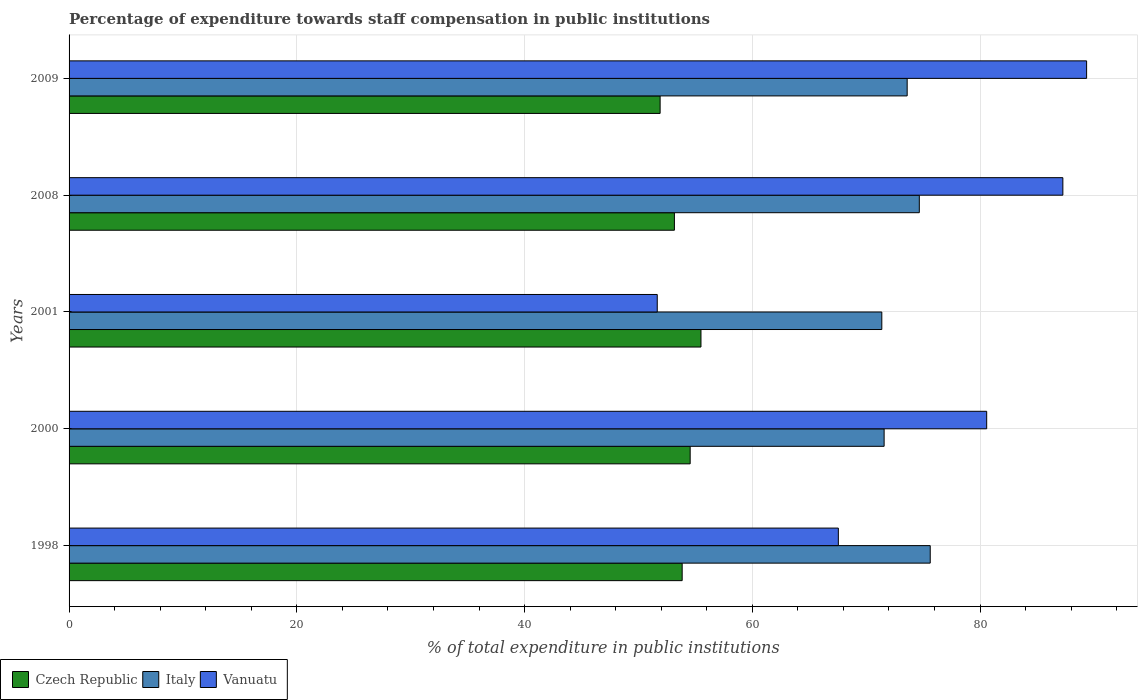How many groups of bars are there?
Your answer should be very brief. 5. Are the number of bars on each tick of the Y-axis equal?
Provide a succinct answer. Yes. What is the label of the 4th group of bars from the top?
Your answer should be compact. 2000. In how many cases, is the number of bars for a given year not equal to the number of legend labels?
Provide a short and direct response. 0. What is the percentage of expenditure towards staff compensation in Vanuatu in 2001?
Give a very brief answer. 51.65. Across all years, what is the maximum percentage of expenditure towards staff compensation in Vanuatu?
Ensure brevity in your answer.  89.36. Across all years, what is the minimum percentage of expenditure towards staff compensation in Italy?
Your response must be concise. 71.37. In which year was the percentage of expenditure towards staff compensation in Vanuatu maximum?
Offer a terse response. 2009. What is the total percentage of expenditure towards staff compensation in Czech Republic in the graph?
Your answer should be very brief. 268.95. What is the difference between the percentage of expenditure towards staff compensation in Italy in 2000 and that in 2009?
Your response must be concise. -2.02. What is the difference between the percentage of expenditure towards staff compensation in Vanuatu in 2009 and the percentage of expenditure towards staff compensation in Czech Republic in 2008?
Your answer should be compact. 36.2. What is the average percentage of expenditure towards staff compensation in Czech Republic per year?
Keep it short and to the point. 53.79. In the year 1998, what is the difference between the percentage of expenditure towards staff compensation in Czech Republic and percentage of expenditure towards staff compensation in Vanuatu?
Your answer should be compact. -13.71. What is the ratio of the percentage of expenditure towards staff compensation in Vanuatu in 2000 to that in 2008?
Your response must be concise. 0.92. Is the percentage of expenditure towards staff compensation in Italy in 2000 less than that in 2009?
Make the answer very short. Yes. Is the difference between the percentage of expenditure towards staff compensation in Czech Republic in 1998 and 2008 greater than the difference between the percentage of expenditure towards staff compensation in Vanuatu in 1998 and 2008?
Provide a short and direct response. Yes. What is the difference between the highest and the second highest percentage of expenditure towards staff compensation in Vanuatu?
Provide a short and direct response. 2.09. What is the difference between the highest and the lowest percentage of expenditure towards staff compensation in Vanuatu?
Your response must be concise. 37.71. What does the 2nd bar from the top in 2001 represents?
Provide a short and direct response. Italy. What does the 2nd bar from the bottom in 1998 represents?
Provide a succinct answer. Italy. How many bars are there?
Make the answer very short. 15. How many years are there in the graph?
Your answer should be very brief. 5. What is the difference between two consecutive major ticks on the X-axis?
Keep it short and to the point. 20. Are the values on the major ticks of X-axis written in scientific E-notation?
Your answer should be compact. No. Does the graph contain any zero values?
Ensure brevity in your answer.  No. Does the graph contain grids?
Your answer should be compact. Yes. How are the legend labels stacked?
Ensure brevity in your answer.  Horizontal. What is the title of the graph?
Ensure brevity in your answer.  Percentage of expenditure towards staff compensation in public institutions. What is the label or title of the X-axis?
Ensure brevity in your answer.  % of total expenditure in public institutions. What is the label or title of the Y-axis?
Your response must be concise. Years. What is the % of total expenditure in public institutions of Czech Republic in 1998?
Provide a succinct answer. 53.84. What is the % of total expenditure in public institutions in Italy in 1998?
Provide a short and direct response. 75.63. What is the % of total expenditure in public institutions of Vanuatu in 1998?
Ensure brevity in your answer.  67.56. What is the % of total expenditure in public institutions in Czech Republic in 2000?
Your answer should be compact. 54.54. What is the % of total expenditure in public institutions in Italy in 2000?
Ensure brevity in your answer.  71.58. What is the % of total expenditure in public institutions of Vanuatu in 2000?
Ensure brevity in your answer.  80.58. What is the % of total expenditure in public institutions in Czech Republic in 2001?
Offer a terse response. 55.49. What is the % of total expenditure in public institutions of Italy in 2001?
Ensure brevity in your answer.  71.37. What is the % of total expenditure in public institutions in Vanuatu in 2001?
Your answer should be compact. 51.65. What is the % of total expenditure in public institutions in Czech Republic in 2008?
Your answer should be compact. 53.16. What is the % of total expenditure in public institutions in Italy in 2008?
Ensure brevity in your answer.  74.67. What is the % of total expenditure in public institutions of Vanuatu in 2008?
Ensure brevity in your answer.  87.27. What is the % of total expenditure in public institutions of Czech Republic in 2009?
Keep it short and to the point. 51.91. What is the % of total expenditure in public institutions in Italy in 2009?
Ensure brevity in your answer.  73.6. What is the % of total expenditure in public institutions in Vanuatu in 2009?
Ensure brevity in your answer.  89.36. Across all years, what is the maximum % of total expenditure in public institutions of Czech Republic?
Make the answer very short. 55.49. Across all years, what is the maximum % of total expenditure in public institutions of Italy?
Your answer should be compact. 75.63. Across all years, what is the maximum % of total expenditure in public institutions in Vanuatu?
Offer a terse response. 89.36. Across all years, what is the minimum % of total expenditure in public institutions in Czech Republic?
Provide a succinct answer. 51.91. Across all years, what is the minimum % of total expenditure in public institutions of Italy?
Provide a succinct answer. 71.37. Across all years, what is the minimum % of total expenditure in public institutions of Vanuatu?
Offer a terse response. 51.65. What is the total % of total expenditure in public institutions of Czech Republic in the graph?
Give a very brief answer. 268.95. What is the total % of total expenditure in public institutions of Italy in the graph?
Keep it short and to the point. 366.85. What is the total % of total expenditure in public institutions in Vanuatu in the graph?
Give a very brief answer. 376.43. What is the difference between the % of total expenditure in public institutions of Czech Republic in 1998 and that in 2000?
Keep it short and to the point. -0.7. What is the difference between the % of total expenditure in public institutions in Italy in 1998 and that in 2000?
Offer a very short reply. 4.05. What is the difference between the % of total expenditure in public institutions in Vanuatu in 1998 and that in 2000?
Offer a terse response. -13.03. What is the difference between the % of total expenditure in public institutions in Czech Republic in 1998 and that in 2001?
Offer a very short reply. -1.65. What is the difference between the % of total expenditure in public institutions of Italy in 1998 and that in 2001?
Ensure brevity in your answer.  4.25. What is the difference between the % of total expenditure in public institutions of Vanuatu in 1998 and that in 2001?
Your answer should be compact. 15.9. What is the difference between the % of total expenditure in public institutions in Czech Republic in 1998 and that in 2008?
Your answer should be compact. 0.68. What is the difference between the % of total expenditure in public institutions of Italy in 1998 and that in 2008?
Give a very brief answer. 0.96. What is the difference between the % of total expenditure in public institutions in Vanuatu in 1998 and that in 2008?
Provide a succinct answer. -19.72. What is the difference between the % of total expenditure in public institutions in Czech Republic in 1998 and that in 2009?
Provide a short and direct response. 1.94. What is the difference between the % of total expenditure in public institutions in Italy in 1998 and that in 2009?
Your response must be concise. 2.02. What is the difference between the % of total expenditure in public institutions of Vanuatu in 1998 and that in 2009?
Give a very brief answer. -21.8. What is the difference between the % of total expenditure in public institutions in Czech Republic in 2000 and that in 2001?
Provide a succinct answer. -0.95. What is the difference between the % of total expenditure in public institutions of Italy in 2000 and that in 2001?
Provide a short and direct response. 0.2. What is the difference between the % of total expenditure in public institutions of Vanuatu in 2000 and that in 2001?
Provide a short and direct response. 28.93. What is the difference between the % of total expenditure in public institutions in Czech Republic in 2000 and that in 2008?
Give a very brief answer. 1.38. What is the difference between the % of total expenditure in public institutions in Italy in 2000 and that in 2008?
Your response must be concise. -3.09. What is the difference between the % of total expenditure in public institutions in Vanuatu in 2000 and that in 2008?
Your response must be concise. -6.69. What is the difference between the % of total expenditure in public institutions of Czech Republic in 2000 and that in 2009?
Give a very brief answer. 2.64. What is the difference between the % of total expenditure in public institutions in Italy in 2000 and that in 2009?
Your answer should be compact. -2.02. What is the difference between the % of total expenditure in public institutions of Vanuatu in 2000 and that in 2009?
Your response must be concise. -8.78. What is the difference between the % of total expenditure in public institutions in Czech Republic in 2001 and that in 2008?
Provide a succinct answer. 2.33. What is the difference between the % of total expenditure in public institutions in Italy in 2001 and that in 2008?
Keep it short and to the point. -3.29. What is the difference between the % of total expenditure in public institutions of Vanuatu in 2001 and that in 2008?
Keep it short and to the point. -35.62. What is the difference between the % of total expenditure in public institutions in Czech Republic in 2001 and that in 2009?
Offer a very short reply. 3.59. What is the difference between the % of total expenditure in public institutions in Italy in 2001 and that in 2009?
Keep it short and to the point. -2.23. What is the difference between the % of total expenditure in public institutions in Vanuatu in 2001 and that in 2009?
Your answer should be very brief. -37.71. What is the difference between the % of total expenditure in public institutions in Czech Republic in 2008 and that in 2009?
Offer a very short reply. 1.25. What is the difference between the % of total expenditure in public institutions in Italy in 2008 and that in 2009?
Your answer should be compact. 1.07. What is the difference between the % of total expenditure in public institutions of Vanuatu in 2008 and that in 2009?
Your answer should be compact. -2.09. What is the difference between the % of total expenditure in public institutions of Czech Republic in 1998 and the % of total expenditure in public institutions of Italy in 2000?
Ensure brevity in your answer.  -17.73. What is the difference between the % of total expenditure in public institutions of Czech Republic in 1998 and the % of total expenditure in public institutions of Vanuatu in 2000?
Ensure brevity in your answer.  -26.74. What is the difference between the % of total expenditure in public institutions of Italy in 1998 and the % of total expenditure in public institutions of Vanuatu in 2000?
Your response must be concise. -4.96. What is the difference between the % of total expenditure in public institutions in Czech Republic in 1998 and the % of total expenditure in public institutions in Italy in 2001?
Provide a succinct answer. -17.53. What is the difference between the % of total expenditure in public institutions of Czech Republic in 1998 and the % of total expenditure in public institutions of Vanuatu in 2001?
Your answer should be very brief. 2.19. What is the difference between the % of total expenditure in public institutions of Italy in 1998 and the % of total expenditure in public institutions of Vanuatu in 2001?
Offer a terse response. 23.97. What is the difference between the % of total expenditure in public institutions in Czech Republic in 1998 and the % of total expenditure in public institutions in Italy in 2008?
Provide a succinct answer. -20.83. What is the difference between the % of total expenditure in public institutions of Czech Republic in 1998 and the % of total expenditure in public institutions of Vanuatu in 2008?
Make the answer very short. -33.43. What is the difference between the % of total expenditure in public institutions of Italy in 1998 and the % of total expenditure in public institutions of Vanuatu in 2008?
Your response must be concise. -11.65. What is the difference between the % of total expenditure in public institutions of Czech Republic in 1998 and the % of total expenditure in public institutions of Italy in 2009?
Your answer should be very brief. -19.76. What is the difference between the % of total expenditure in public institutions of Czech Republic in 1998 and the % of total expenditure in public institutions of Vanuatu in 2009?
Your response must be concise. -35.52. What is the difference between the % of total expenditure in public institutions in Italy in 1998 and the % of total expenditure in public institutions in Vanuatu in 2009?
Offer a very short reply. -13.73. What is the difference between the % of total expenditure in public institutions in Czech Republic in 2000 and the % of total expenditure in public institutions in Italy in 2001?
Your response must be concise. -16.83. What is the difference between the % of total expenditure in public institutions in Czech Republic in 2000 and the % of total expenditure in public institutions in Vanuatu in 2001?
Offer a very short reply. 2.89. What is the difference between the % of total expenditure in public institutions in Italy in 2000 and the % of total expenditure in public institutions in Vanuatu in 2001?
Your answer should be compact. 19.92. What is the difference between the % of total expenditure in public institutions in Czech Republic in 2000 and the % of total expenditure in public institutions in Italy in 2008?
Make the answer very short. -20.12. What is the difference between the % of total expenditure in public institutions in Czech Republic in 2000 and the % of total expenditure in public institutions in Vanuatu in 2008?
Make the answer very short. -32.73. What is the difference between the % of total expenditure in public institutions of Italy in 2000 and the % of total expenditure in public institutions of Vanuatu in 2008?
Provide a short and direct response. -15.7. What is the difference between the % of total expenditure in public institutions of Czech Republic in 2000 and the % of total expenditure in public institutions of Italy in 2009?
Your answer should be very brief. -19.06. What is the difference between the % of total expenditure in public institutions of Czech Republic in 2000 and the % of total expenditure in public institutions of Vanuatu in 2009?
Your answer should be compact. -34.82. What is the difference between the % of total expenditure in public institutions of Italy in 2000 and the % of total expenditure in public institutions of Vanuatu in 2009?
Provide a succinct answer. -17.78. What is the difference between the % of total expenditure in public institutions of Czech Republic in 2001 and the % of total expenditure in public institutions of Italy in 2008?
Offer a very short reply. -19.18. What is the difference between the % of total expenditure in public institutions in Czech Republic in 2001 and the % of total expenditure in public institutions in Vanuatu in 2008?
Your answer should be compact. -31.78. What is the difference between the % of total expenditure in public institutions of Italy in 2001 and the % of total expenditure in public institutions of Vanuatu in 2008?
Provide a short and direct response. -15.9. What is the difference between the % of total expenditure in public institutions of Czech Republic in 2001 and the % of total expenditure in public institutions of Italy in 2009?
Provide a succinct answer. -18.11. What is the difference between the % of total expenditure in public institutions in Czech Republic in 2001 and the % of total expenditure in public institutions in Vanuatu in 2009?
Provide a succinct answer. -33.87. What is the difference between the % of total expenditure in public institutions of Italy in 2001 and the % of total expenditure in public institutions of Vanuatu in 2009?
Provide a short and direct response. -17.99. What is the difference between the % of total expenditure in public institutions of Czech Republic in 2008 and the % of total expenditure in public institutions of Italy in 2009?
Give a very brief answer. -20.44. What is the difference between the % of total expenditure in public institutions of Czech Republic in 2008 and the % of total expenditure in public institutions of Vanuatu in 2009?
Provide a short and direct response. -36.2. What is the difference between the % of total expenditure in public institutions in Italy in 2008 and the % of total expenditure in public institutions in Vanuatu in 2009?
Offer a very short reply. -14.69. What is the average % of total expenditure in public institutions in Czech Republic per year?
Offer a terse response. 53.79. What is the average % of total expenditure in public institutions of Italy per year?
Keep it short and to the point. 73.37. What is the average % of total expenditure in public institutions in Vanuatu per year?
Ensure brevity in your answer.  75.29. In the year 1998, what is the difference between the % of total expenditure in public institutions of Czech Republic and % of total expenditure in public institutions of Italy?
Keep it short and to the point. -21.78. In the year 1998, what is the difference between the % of total expenditure in public institutions in Czech Republic and % of total expenditure in public institutions in Vanuatu?
Provide a succinct answer. -13.71. In the year 1998, what is the difference between the % of total expenditure in public institutions in Italy and % of total expenditure in public institutions in Vanuatu?
Ensure brevity in your answer.  8.07. In the year 2000, what is the difference between the % of total expenditure in public institutions in Czech Republic and % of total expenditure in public institutions in Italy?
Offer a terse response. -17.03. In the year 2000, what is the difference between the % of total expenditure in public institutions of Czech Republic and % of total expenditure in public institutions of Vanuatu?
Ensure brevity in your answer.  -26.04. In the year 2000, what is the difference between the % of total expenditure in public institutions in Italy and % of total expenditure in public institutions in Vanuatu?
Provide a short and direct response. -9.01. In the year 2001, what is the difference between the % of total expenditure in public institutions in Czech Republic and % of total expenditure in public institutions in Italy?
Offer a terse response. -15.88. In the year 2001, what is the difference between the % of total expenditure in public institutions of Czech Republic and % of total expenditure in public institutions of Vanuatu?
Provide a succinct answer. 3.84. In the year 2001, what is the difference between the % of total expenditure in public institutions in Italy and % of total expenditure in public institutions in Vanuatu?
Your response must be concise. 19.72. In the year 2008, what is the difference between the % of total expenditure in public institutions of Czech Republic and % of total expenditure in public institutions of Italy?
Give a very brief answer. -21.51. In the year 2008, what is the difference between the % of total expenditure in public institutions of Czech Republic and % of total expenditure in public institutions of Vanuatu?
Offer a terse response. -34.11. In the year 2008, what is the difference between the % of total expenditure in public institutions in Italy and % of total expenditure in public institutions in Vanuatu?
Your answer should be compact. -12.61. In the year 2009, what is the difference between the % of total expenditure in public institutions in Czech Republic and % of total expenditure in public institutions in Italy?
Keep it short and to the point. -21.7. In the year 2009, what is the difference between the % of total expenditure in public institutions in Czech Republic and % of total expenditure in public institutions in Vanuatu?
Ensure brevity in your answer.  -37.45. In the year 2009, what is the difference between the % of total expenditure in public institutions in Italy and % of total expenditure in public institutions in Vanuatu?
Ensure brevity in your answer.  -15.76. What is the ratio of the % of total expenditure in public institutions of Czech Republic in 1998 to that in 2000?
Your response must be concise. 0.99. What is the ratio of the % of total expenditure in public institutions of Italy in 1998 to that in 2000?
Offer a terse response. 1.06. What is the ratio of the % of total expenditure in public institutions of Vanuatu in 1998 to that in 2000?
Your answer should be compact. 0.84. What is the ratio of the % of total expenditure in public institutions of Czech Republic in 1998 to that in 2001?
Give a very brief answer. 0.97. What is the ratio of the % of total expenditure in public institutions of Italy in 1998 to that in 2001?
Provide a short and direct response. 1.06. What is the ratio of the % of total expenditure in public institutions in Vanuatu in 1998 to that in 2001?
Provide a short and direct response. 1.31. What is the ratio of the % of total expenditure in public institutions in Czech Republic in 1998 to that in 2008?
Provide a succinct answer. 1.01. What is the ratio of the % of total expenditure in public institutions in Italy in 1998 to that in 2008?
Make the answer very short. 1.01. What is the ratio of the % of total expenditure in public institutions of Vanuatu in 1998 to that in 2008?
Offer a terse response. 0.77. What is the ratio of the % of total expenditure in public institutions in Czech Republic in 1998 to that in 2009?
Provide a succinct answer. 1.04. What is the ratio of the % of total expenditure in public institutions in Italy in 1998 to that in 2009?
Give a very brief answer. 1.03. What is the ratio of the % of total expenditure in public institutions in Vanuatu in 1998 to that in 2009?
Your answer should be compact. 0.76. What is the ratio of the % of total expenditure in public institutions of Czech Republic in 2000 to that in 2001?
Your answer should be very brief. 0.98. What is the ratio of the % of total expenditure in public institutions of Italy in 2000 to that in 2001?
Your answer should be very brief. 1. What is the ratio of the % of total expenditure in public institutions in Vanuatu in 2000 to that in 2001?
Make the answer very short. 1.56. What is the ratio of the % of total expenditure in public institutions in Italy in 2000 to that in 2008?
Make the answer very short. 0.96. What is the ratio of the % of total expenditure in public institutions of Vanuatu in 2000 to that in 2008?
Provide a succinct answer. 0.92. What is the ratio of the % of total expenditure in public institutions in Czech Republic in 2000 to that in 2009?
Ensure brevity in your answer.  1.05. What is the ratio of the % of total expenditure in public institutions of Italy in 2000 to that in 2009?
Keep it short and to the point. 0.97. What is the ratio of the % of total expenditure in public institutions of Vanuatu in 2000 to that in 2009?
Ensure brevity in your answer.  0.9. What is the ratio of the % of total expenditure in public institutions in Czech Republic in 2001 to that in 2008?
Offer a very short reply. 1.04. What is the ratio of the % of total expenditure in public institutions in Italy in 2001 to that in 2008?
Your answer should be compact. 0.96. What is the ratio of the % of total expenditure in public institutions of Vanuatu in 2001 to that in 2008?
Give a very brief answer. 0.59. What is the ratio of the % of total expenditure in public institutions in Czech Republic in 2001 to that in 2009?
Provide a succinct answer. 1.07. What is the ratio of the % of total expenditure in public institutions of Italy in 2001 to that in 2009?
Your answer should be compact. 0.97. What is the ratio of the % of total expenditure in public institutions of Vanuatu in 2001 to that in 2009?
Your response must be concise. 0.58. What is the ratio of the % of total expenditure in public institutions of Czech Republic in 2008 to that in 2009?
Offer a very short reply. 1.02. What is the ratio of the % of total expenditure in public institutions of Italy in 2008 to that in 2009?
Ensure brevity in your answer.  1.01. What is the ratio of the % of total expenditure in public institutions in Vanuatu in 2008 to that in 2009?
Your answer should be compact. 0.98. What is the difference between the highest and the second highest % of total expenditure in public institutions in Czech Republic?
Keep it short and to the point. 0.95. What is the difference between the highest and the second highest % of total expenditure in public institutions in Vanuatu?
Your answer should be very brief. 2.09. What is the difference between the highest and the lowest % of total expenditure in public institutions of Czech Republic?
Your answer should be very brief. 3.59. What is the difference between the highest and the lowest % of total expenditure in public institutions of Italy?
Offer a very short reply. 4.25. What is the difference between the highest and the lowest % of total expenditure in public institutions in Vanuatu?
Keep it short and to the point. 37.71. 